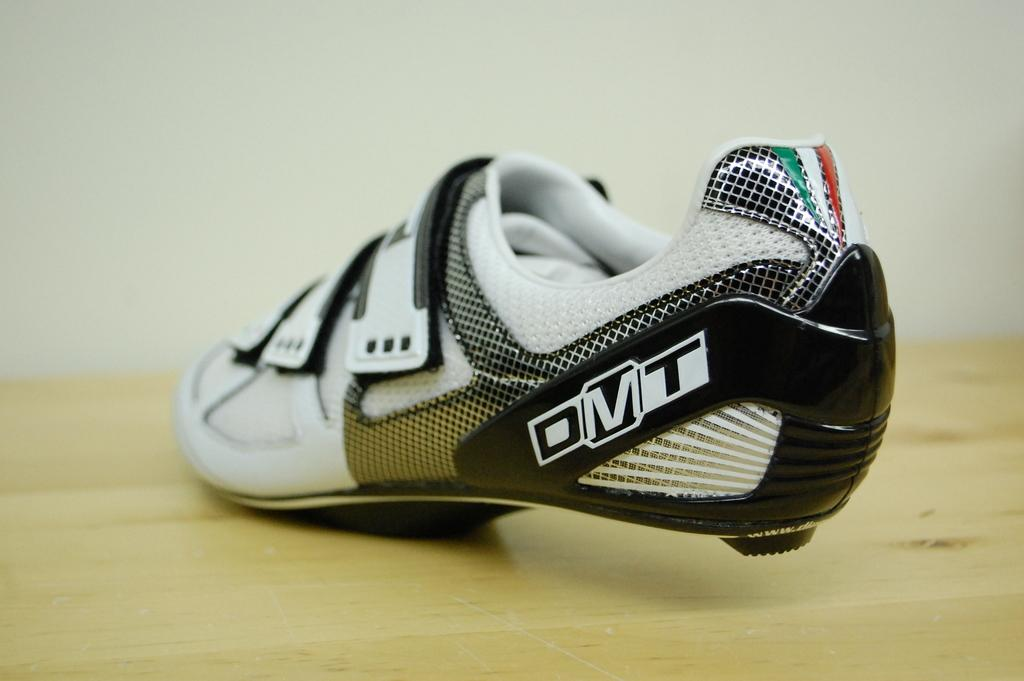What object is the main subject of the image? There is a shoe in the image. On what type of surface is the shoe placed? The shoe is on a wooden surface. What can be seen in the background of the image? There is a wall in the background of the image. What type of coat is hanging on the street in the image? There is no coat or street present in the image; it only features a shoe on a wooden surface with a wall in the background. 